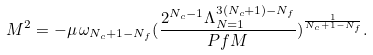<formula> <loc_0><loc_0><loc_500><loc_500>M ^ { 2 } = - \mu \, \omega _ { N _ { c } + 1 - N _ { f } } ( \frac { 2 ^ { N _ { c } - 1 } \Lambda _ { N = 1 } ^ { 3 ( N _ { c } + 1 ) - N _ { f } } } { P f M } ) ^ { \frac { 1 } { N _ { c } + 1 - N _ { f } } } .</formula> 